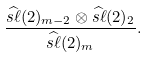Convert formula to latex. <formula><loc_0><loc_0><loc_500><loc_500>\frac { \widehat { s \ell } ( 2 ) _ { m - 2 } \otimes \widehat { s \ell } ( 2 ) _ { 2 } } { \widehat { s \ell } ( 2 ) _ { m } } .</formula> 